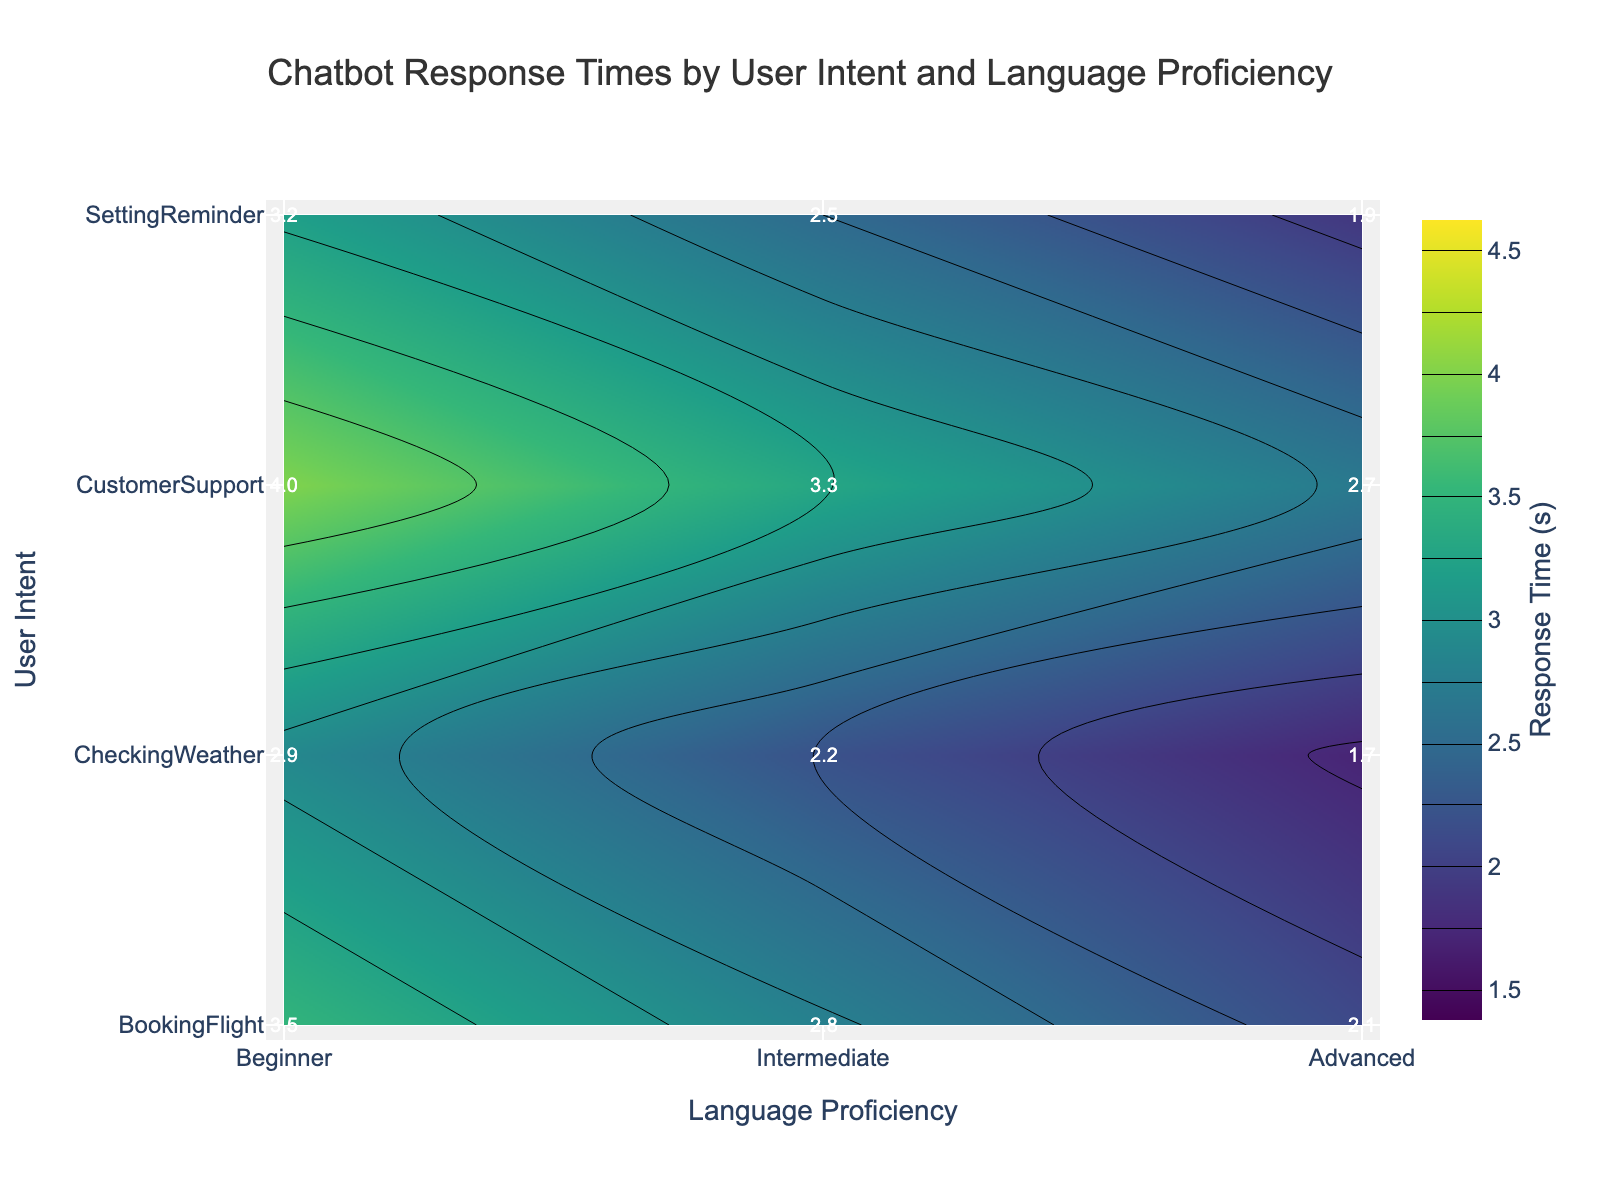What is the title of the figure? The title of the figure is usually located at the top and summarizes what the figure is about. In this case, it is "Chatbot Response Times by User Intent and Language Proficiency".
Answer: Chatbot Response Times by User Intent and Language Proficiency What are the axes labels in the plot? The axes labels are typically located along the axes. The x-axis is labeled "Language Proficiency," and the y-axis is labeled "User Intent."
Answer: Language Proficiency (x-axis), User Intent (y-axis) Which user intent has the highest response time for beginner proficiency? By looking at the y-axis for the "Beginner" level and finding the highest value in the corresponding row, "Customer Support" has the highest response time of 4.0 seconds.
Answer: Customer Support What is the response time for "Setting Reminder" at intermediate proficiency? The label at the intersection of "Setting Reminder" (y-axis) and "Intermediate" (x-axis) will give the response time, which is 2.5 seconds.
Answer: 2.5 seconds Compare the response times for "Booking Flight" across all proficiency levels. Which proficiency has the fastest response time? By comparing the values in the "Booking Flight" row for Beginner (3.5), Intermediate (2.8), and Advanced (2.1), the Advanced proficiency has the fastest response time.
Answer: Advanced What is the average response time for "Checking Weather" across different proficiency levels? Sum the response times for "Checking Weather" (2.9 for Beginner, 2.2 for Intermediate, and 1.7 for Advanced) and divide by the number of levels (3). Average response time = (2.9 + 2.2 + 1.7) / 3 = 2.27 seconds.
Answer: 2.27 seconds Which proficiency level generally has the lowest response times across all user intents? By examining the rows, the "Advanced" proficiency level consistently shows the lowest response times compared to "Beginner" and "Intermediate" levels.
Answer: Advanced How does the response time for "Customer Support" at intermediate proficiency compare to that at advanced proficiency? The response time for "Customer Support" at Intermediate is 3.3 seconds, whereas for Advanced, it is 2.7 seconds. Intermediate is higher than Advanced.
Answer: Intermediate is higher What is the range of response times displayed in the plot? The range of response times can be identified by the color bar and the contours. The minimum value is 1.7 seconds and the maximum value is 4.0 seconds.
Answer: 1.7 to 4.0 seconds At what proficiency level does the "Setting Reminder" user intent have a response time under 2 seconds? By checking the "Setting Reminder" row, only the Advanced proficiency level has a response time under 2 seconds, specifically 1.9 seconds.
Answer: Advanced 